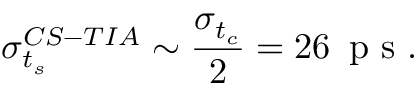<formula> <loc_0><loc_0><loc_500><loc_500>\sigma _ { t _ { s } } ^ { C S - T I A } \sim \frac { \sigma _ { t _ { c } } } { 2 } = 2 6 \, p s .</formula> 